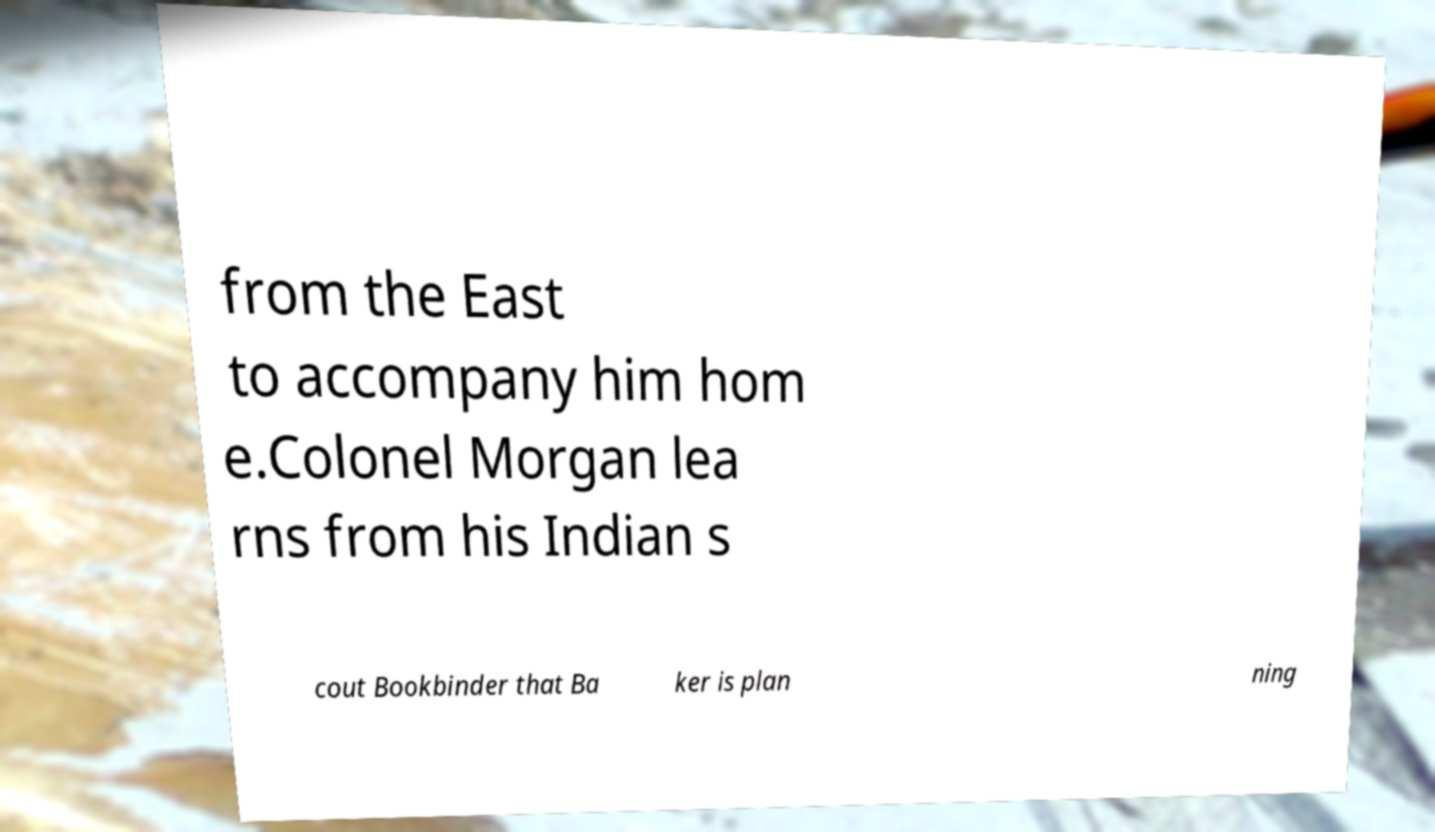Can you read and provide the text displayed in the image?This photo seems to have some interesting text. Can you extract and type it out for me? from the East to accompany him hom e.Colonel Morgan lea rns from his Indian s cout Bookbinder that Ba ker is plan ning 